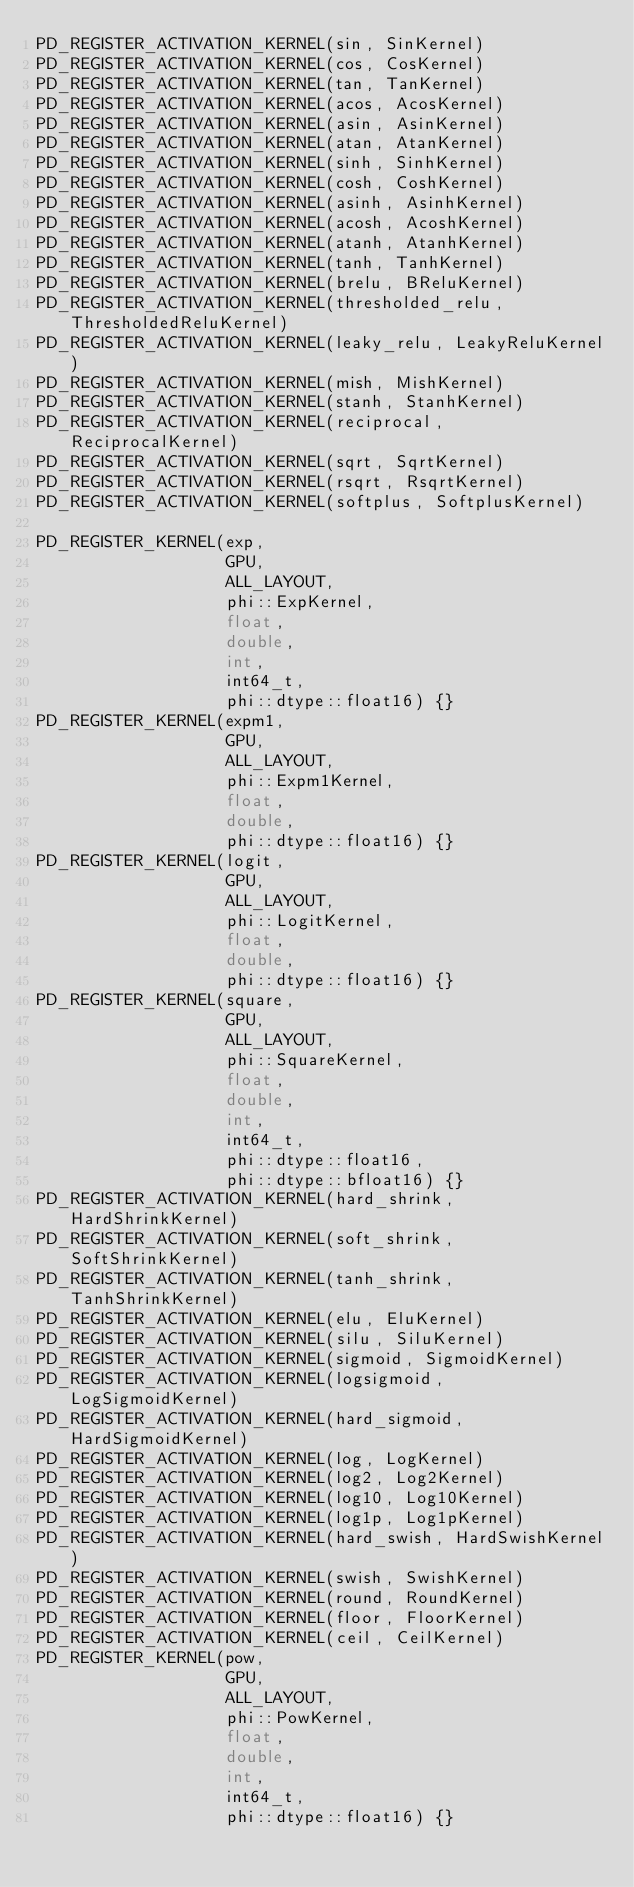<code> <loc_0><loc_0><loc_500><loc_500><_Cuda_>PD_REGISTER_ACTIVATION_KERNEL(sin, SinKernel)
PD_REGISTER_ACTIVATION_KERNEL(cos, CosKernel)
PD_REGISTER_ACTIVATION_KERNEL(tan, TanKernel)
PD_REGISTER_ACTIVATION_KERNEL(acos, AcosKernel)
PD_REGISTER_ACTIVATION_KERNEL(asin, AsinKernel)
PD_REGISTER_ACTIVATION_KERNEL(atan, AtanKernel)
PD_REGISTER_ACTIVATION_KERNEL(sinh, SinhKernel)
PD_REGISTER_ACTIVATION_KERNEL(cosh, CoshKernel)
PD_REGISTER_ACTIVATION_KERNEL(asinh, AsinhKernel)
PD_REGISTER_ACTIVATION_KERNEL(acosh, AcoshKernel)
PD_REGISTER_ACTIVATION_KERNEL(atanh, AtanhKernel)
PD_REGISTER_ACTIVATION_KERNEL(tanh, TanhKernel)
PD_REGISTER_ACTIVATION_KERNEL(brelu, BReluKernel)
PD_REGISTER_ACTIVATION_KERNEL(thresholded_relu, ThresholdedReluKernel)
PD_REGISTER_ACTIVATION_KERNEL(leaky_relu, LeakyReluKernel)
PD_REGISTER_ACTIVATION_KERNEL(mish, MishKernel)
PD_REGISTER_ACTIVATION_KERNEL(stanh, StanhKernel)
PD_REGISTER_ACTIVATION_KERNEL(reciprocal, ReciprocalKernel)
PD_REGISTER_ACTIVATION_KERNEL(sqrt, SqrtKernel)
PD_REGISTER_ACTIVATION_KERNEL(rsqrt, RsqrtKernel)
PD_REGISTER_ACTIVATION_KERNEL(softplus, SoftplusKernel)

PD_REGISTER_KERNEL(exp,
                   GPU,
                   ALL_LAYOUT,
                   phi::ExpKernel,
                   float,
                   double,
                   int,
                   int64_t,
                   phi::dtype::float16) {}
PD_REGISTER_KERNEL(expm1,
                   GPU,
                   ALL_LAYOUT,
                   phi::Expm1Kernel,
                   float,
                   double,
                   phi::dtype::float16) {}
PD_REGISTER_KERNEL(logit,
                   GPU,
                   ALL_LAYOUT,
                   phi::LogitKernel,
                   float,
                   double,
                   phi::dtype::float16) {}
PD_REGISTER_KERNEL(square,
                   GPU,
                   ALL_LAYOUT,
                   phi::SquareKernel,
                   float,
                   double,
                   int,
                   int64_t,
                   phi::dtype::float16,
                   phi::dtype::bfloat16) {}
PD_REGISTER_ACTIVATION_KERNEL(hard_shrink, HardShrinkKernel)
PD_REGISTER_ACTIVATION_KERNEL(soft_shrink, SoftShrinkKernel)
PD_REGISTER_ACTIVATION_KERNEL(tanh_shrink, TanhShrinkKernel)
PD_REGISTER_ACTIVATION_KERNEL(elu, EluKernel)
PD_REGISTER_ACTIVATION_KERNEL(silu, SiluKernel)
PD_REGISTER_ACTIVATION_KERNEL(sigmoid, SigmoidKernel)
PD_REGISTER_ACTIVATION_KERNEL(logsigmoid, LogSigmoidKernel)
PD_REGISTER_ACTIVATION_KERNEL(hard_sigmoid, HardSigmoidKernel)
PD_REGISTER_ACTIVATION_KERNEL(log, LogKernel)
PD_REGISTER_ACTIVATION_KERNEL(log2, Log2Kernel)
PD_REGISTER_ACTIVATION_KERNEL(log10, Log10Kernel)
PD_REGISTER_ACTIVATION_KERNEL(log1p, Log1pKernel)
PD_REGISTER_ACTIVATION_KERNEL(hard_swish, HardSwishKernel)
PD_REGISTER_ACTIVATION_KERNEL(swish, SwishKernel)
PD_REGISTER_ACTIVATION_KERNEL(round, RoundKernel)
PD_REGISTER_ACTIVATION_KERNEL(floor, FloorKernel)
PD_REGISTER_ACTIVATION_KERNEL(ceil, CeilKernel)
PD_REGISTER_KERNEL(pow,
                   GPU,
                   ALL_LAYOUT,
                   phi::PowKernel,
                   float,
                   double,
                   int,
                   int64_t,
                   phi::dtype::float16) {}
</code> 